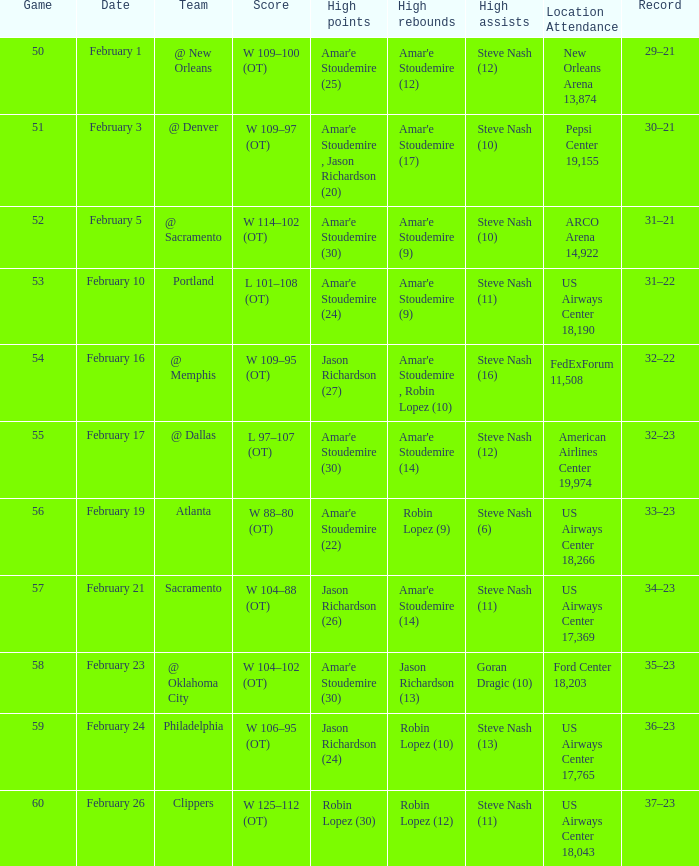On which date did the 109-95 (ot) score occur? February 16. Can you give me this table as a dict? {'header': ['Game', 'Date', 'Team', 'Score', 'High points', 'High rebounds', 'High assists', 'Location Attendance', 'Record'], 'rows': [['50', 'February 1', '@ New Orleans', 'W 109–100 (OT)', "Amar'e Stoudemire (25)", "Amar'e Stoudemire (12)", 'Steve Nash (12)', 'New Orleans Arena 13,874', '29–21'], ['51', 'February 3', '@ Denver', 'W 109–97 (OT)', "Amar'e Stoudemire , Jason Richardson (20)", "Amar'e Stoudemire (17)", 'Steve Nash (10)', 'Pepsi Center 19,155', '30–21'], ['52', 'February 5', '@ Sacramento', 'W 114–102 (OT)', "Amar'e Stoudemire (30)", "Amar'e Stoudemire (9)", 'Steve Nash (10)', 'ARCO Arena 14,922', '31–21'], ['53', 'February 10', 'Portland', 'L 101–108 (OT)', "Amar'e Stoudemire (24)", "Amar'e Stoudemire (9)", 'Steve Nash (11)', 'US Airways Center 18,190', '31–22'], ['54', 'February 16', '@ Memphis', 'W 109–95 (OT)', 'Jason Richardson (27)', "Amar'e Stoudemire , Robin Lopez (10)", 'Steve Nash (16)', 'FedExForum 11,508', '32–22'], ['55', 'February 17', '@ Dallas', 'L 97–107 (OT)', "Amar'e Stoudemire (30)", "Amar'e Stoudemire (14)", 'Steve Nash (12)', 'American Airlines Center 19,974', '32–23'], ['56', 'February 19', 'Atlanta', 'W 88–80 (OT)', "Amar'e Stoudemire (22)", 'Robin Lopez (9)', 'Steve Nash (6)', 'US Airways Center 18,266', '33–23'], ['57', 'February 21', 'Sacramento', 'W 104–88 (OT)', 'Jason Richardson (26)', "Amar'e Stoudemire (14)", 'Steve Nash (11)', 'US Airways Center 17,369', '34–23'], ['58', 'February 23', '@ Oklahoma City', 'W 104–102 (OT)', "Amar'e Stoudemire (30)", 'Jason Richardson (13)', 'Goran Dragic (10)', 'Ford Center 18,203', '35–23'], ['59', 'February 24', 'Philadelphia', 'W 106–95 (OT)', 'Jason Richardson (24)', 'Robin Lopez (10)', 'Steve Nash (13)', 'US Airways Center 17,765', '36–23'], ['60', 'February 26', 'Clippers', 'W 125–112 (OT)', 'Robin Lopez (30)', 'Robin Lopez (12)', 'Steve Nash (11)', 'US Airways Center 18,043', '37–23']]} 